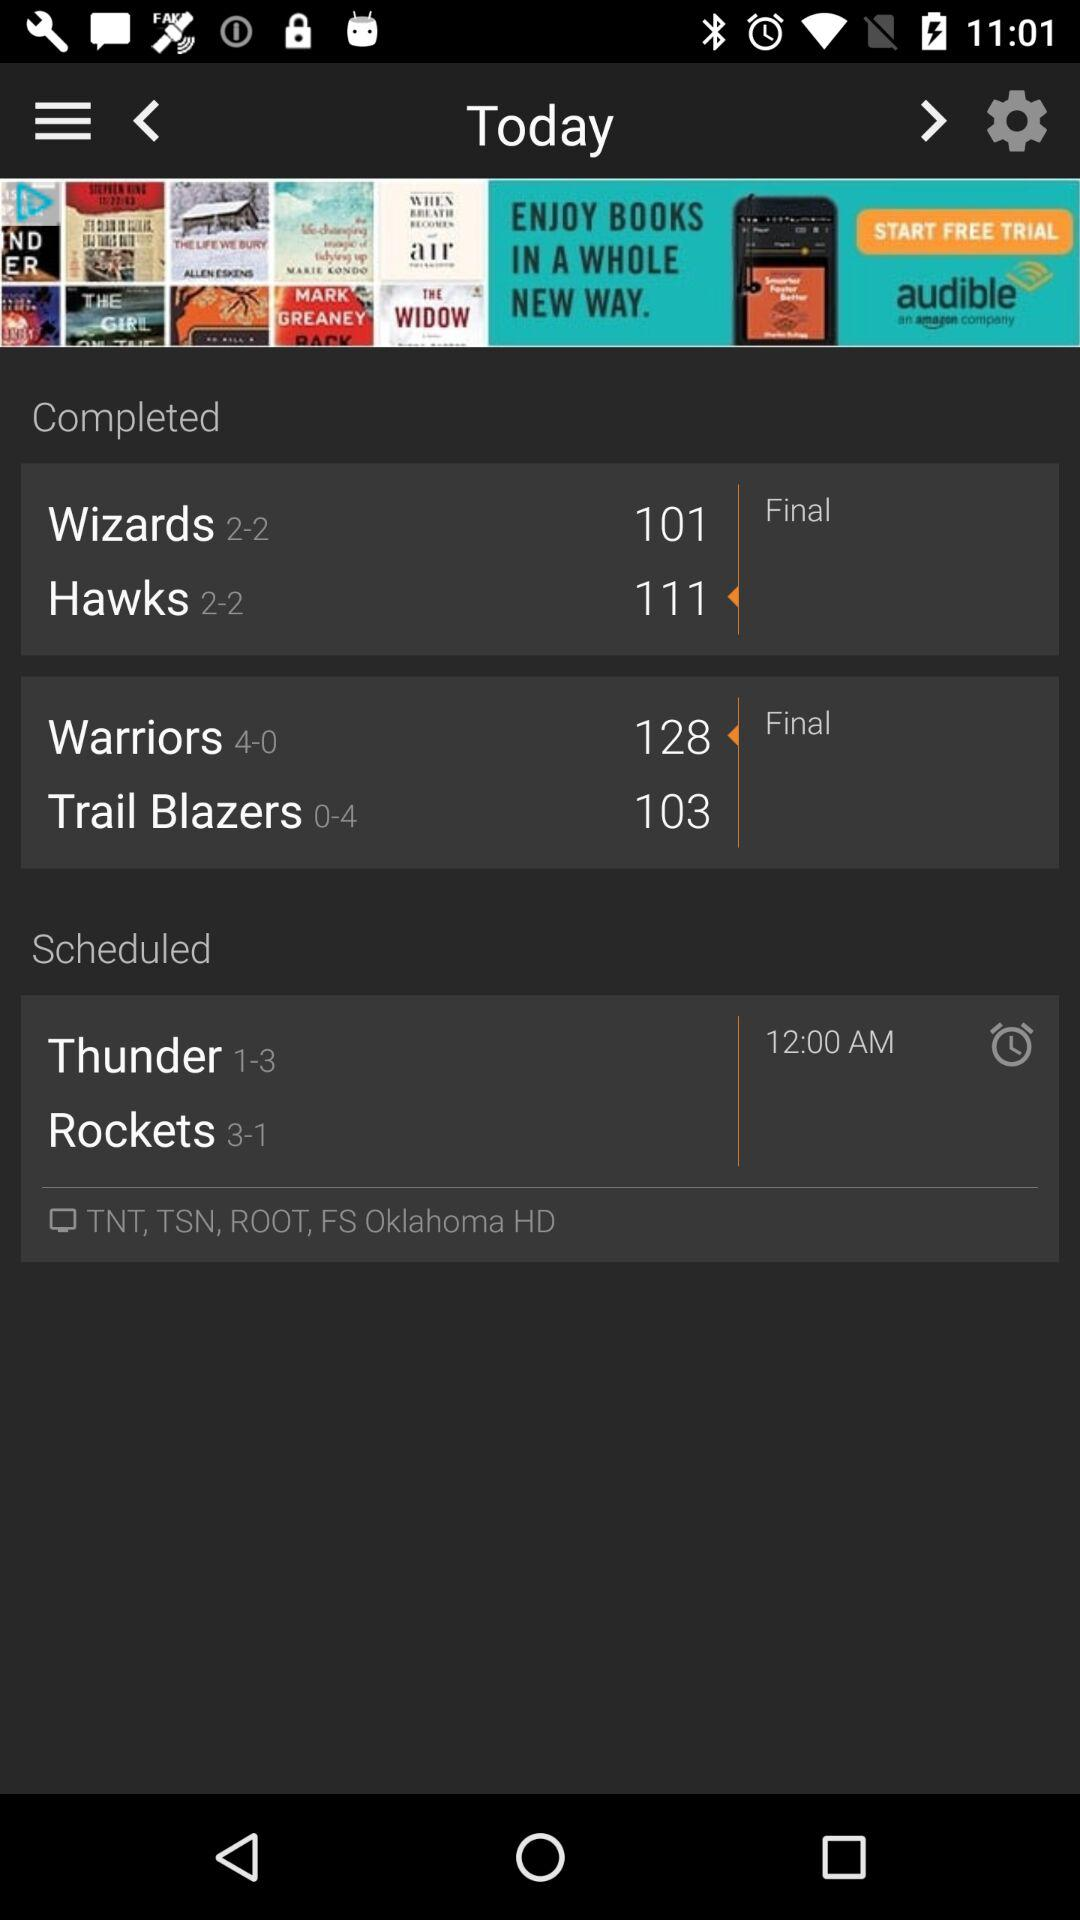How many wizards are there?
When the provided information is insufficient, respond with <no answer>. <no answer> 